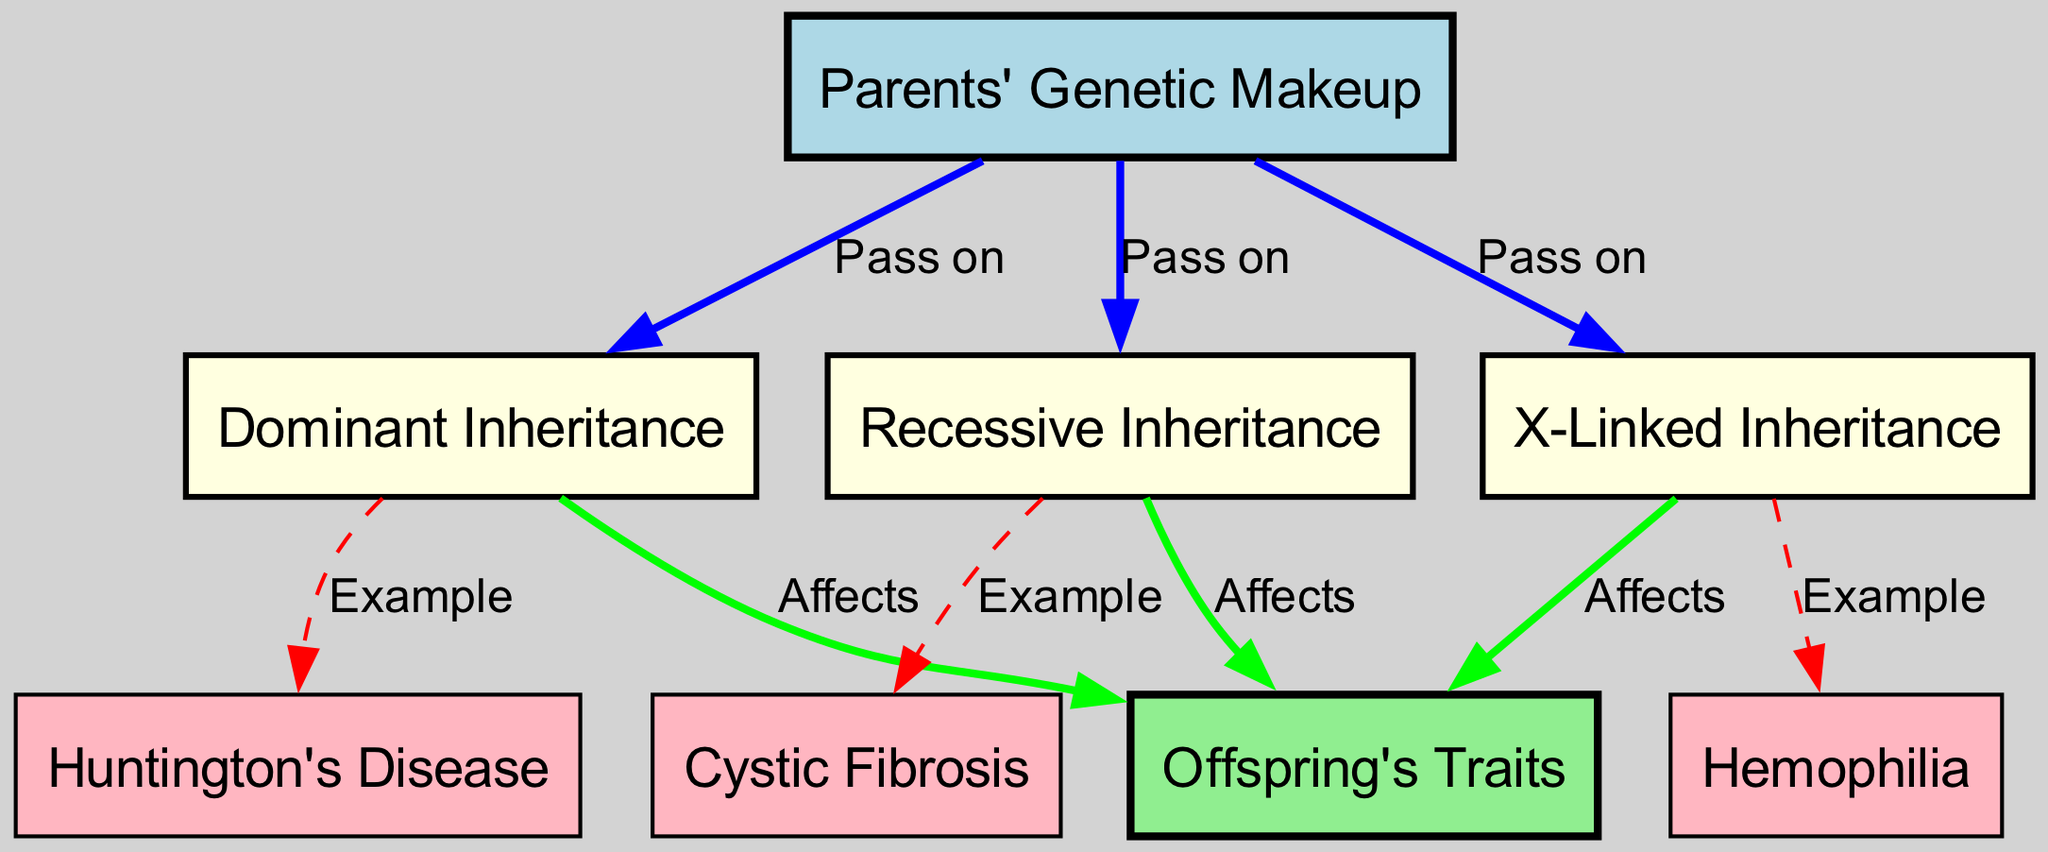What are the three types of inheritance depicted in the diagram? The diagram shows three distinct types of inheritance: Dominant, Recessive, and X-Linked, as highlighted in the nodes connected to the Parents' Genetic Makeup.
Answer: Dominant, Recessive, X-Linked How many examples of hereditary conditions are mentioned in the diagram? There are three examples mentioned for hereditary conditions: Huntington's Disease, Cystic Fibrosis, and Hemophilia, each connected to their respective inheritance types.
Answer: Three Which hereditary condition is associated with Dominant inheritance? The diagram indicates that Huntington's Disease is an example of a condition linked to Dominant inheritance, as shown by the direct edge from the Dominant node to the Huntington's node.
Answer: Huntington's Disease From which inheritance type is Cystic Fibrosis passed down? Cystic Fibrosis is associated with Recessive inheritance, as depicted in the diagram where the Recessive node is connected to the Cystic Fibrosis node.
Answer: Recessive What is the relationship between Parents and Offspring in the context of genetic traits? The diagram illustrates that Parents pass on their genetic traits (both Dominant, Recessive, and X-Linked) to Offspring, indicated by the directed edges leading to the Offspring node.
Answer: Pass on How does X-Linked inheritance affect the offspring? X-Linked inheritance impacts Offspring, as shown by the directed edge from X-Linked inheritance to Offspring, demonstrating the flow of genetic traits.
Answer: Affects What is the significance of the dashed edges in the diagram? The dashed edges signify examples of specific hereditary conditions related to their respective inheritance types, indicating that examples are provided for visualization purposes.
Answer: Examples 